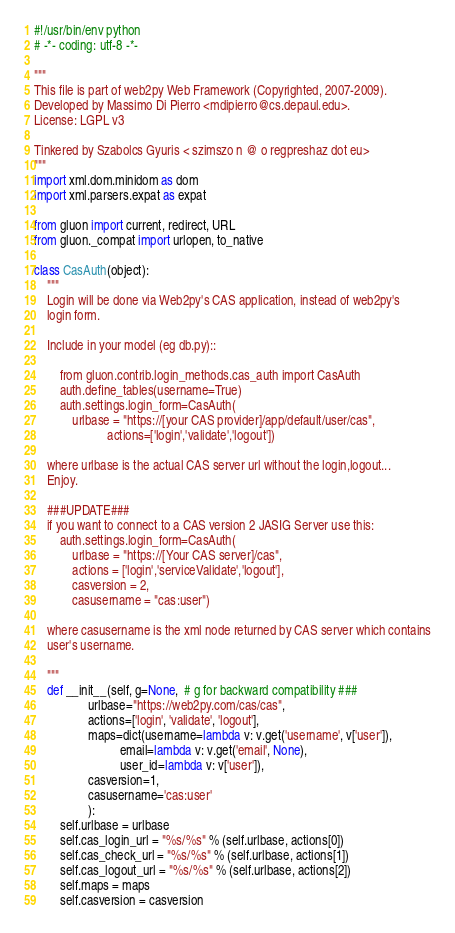<code> <loc_0><loc_0><loc_500><loc_500><_Python_>#!/usr/bin/env python
# -*- coding: utf-8 -*-

"""
This file is part of web2py Web Framework (Copyrighted, 2007-2009).
Developed by Massimo Di Pierro <mdipierro@cs.depaul.edu>.
License: LGPL v3

Tinkered by Szabolcs Gyuris < szimszo n @ o regpreshaz dot eu>
"""
import xml.dom.minidom as dom
import xml.parsers.expat as expat

from gluon import current, redirect, URL
from gluon._compat import urlopen, to_native

class CasAuth(object):
    """
    Login will be done via Web2py's CAS application, instead of web2py's
    login form.

    Include in your model (eg db.py)::

        from gluon.contrib.login_methods.cas_auth import CasAuth
        auth.define_tables(username=True)
        auth.settings.login_form=CasAuth(
            urlbase = "https://[your CAS provider]/app/default/user/cas",
                       actions=['login','validate','logout'])

    where urlbase is the actual CAS server url without the login,logout...
    Enjoy.

    ###UPDATE###
    if you want to connect to a CAS version 2 JASIG Server use this:
        auth.settings.login_form=CasAuth(
            urlbase = "https://[Your CAS server]/cas",
            actions = ['login','serviceValidate','logout'],
            casversion = 2,
            casusername = "cas:user")

    where casusername is the xml node returned by CAS server which contains
    user's username.

    """
    def __init__(self, g=None,  # g for backward compatibility ###
                 urlbase="https://web2py.com/cas/cas",
                 actions=['login', 'validate', 'logout'],
                 maps=dict(username=lambda v: v.get('username', v['user']),
                           email=lambda v: v.get('email', None),
                           user_id=lambda v: v['user']),
                 casversion=1,
                 casusername='cas:user'
                 ):
        self.urlbase = urlbase
        self.cas_login_url = "%s/%s" % (self.urlbase, actions[0])
        self.cas_check_url = "%s/%s" % (self.urlbase, actions[1])
        self.cas_logout_url = "%s/%s" % (self.urlbase, actions[2])
        self.maps = maps
        self.casversion = casversion</code> 